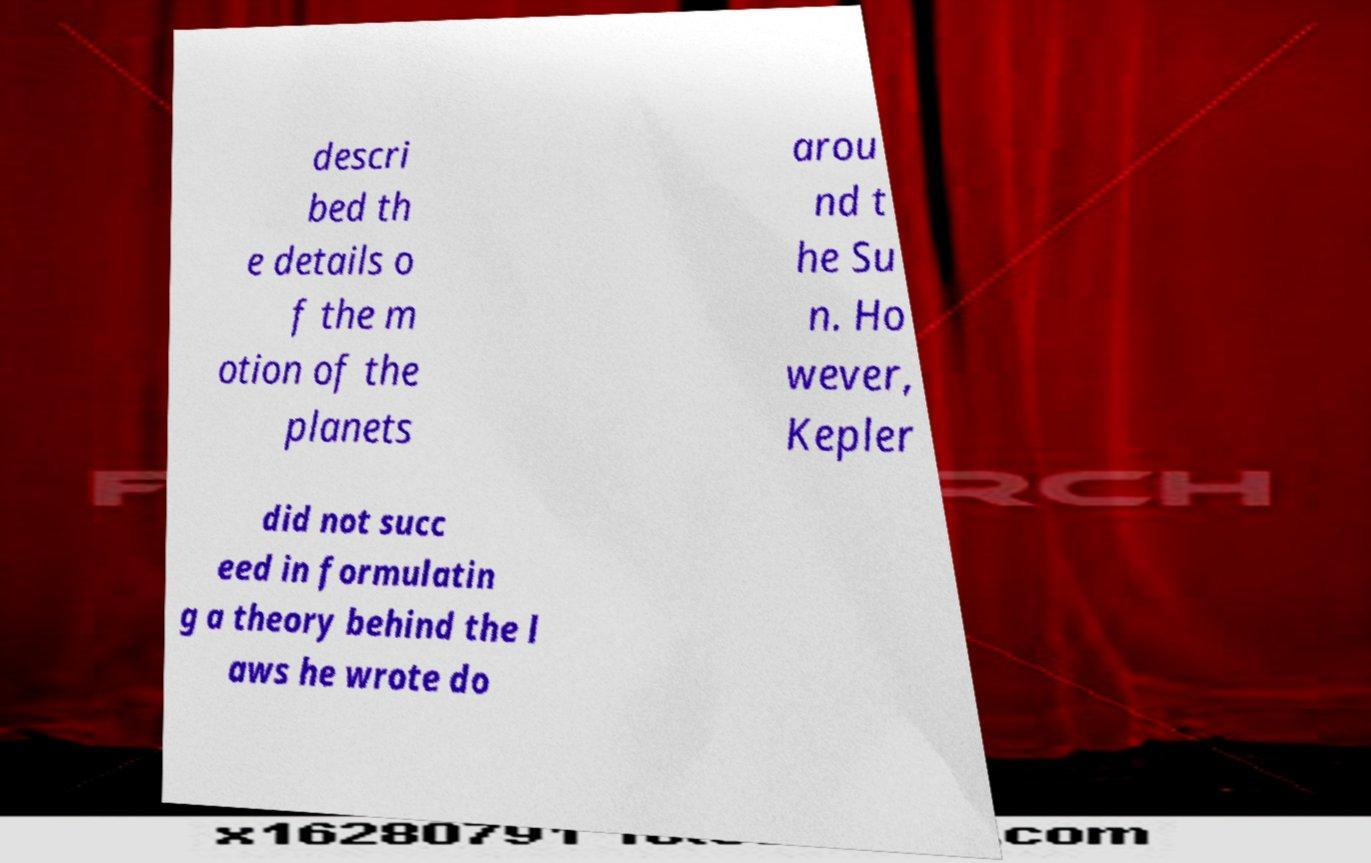For documentation purposes, I need the text within this image transcribed. Could you provide that? descri bed th e details o f the m otion of the planets arou nd t he Su n. Ho wever, Kepler did not succ eed in formulatin g a theory behind the l aws he wrote do 